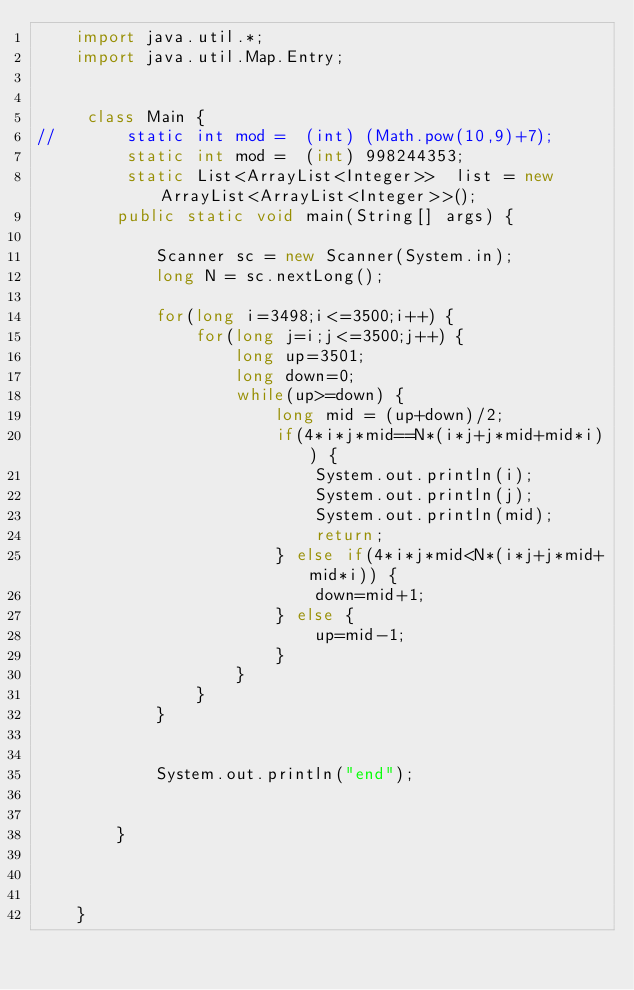<code> <loc_0><loc_0><loc_500><loc_500><_Java_>	import java.util.*;
	import java.util.Map.Entry;
	 
	 
	 class Main {
//		 static int mod =  (int) (Math.pow(10,9)+7);
		 static int mod =  (int) 998244353;
		 static List<ArrayList<Integer>>  list = new ArrayList<ArrayList<Integer>>();
	    public static void main(String[] args) {
	    	
	        Scanner sc = new Scanner(System.in);
	        long N = sc.nextLong();	

	        for(long i=3498;i<=3500;i++) {
	        	for(long j=i;j<=3500;j++) {
	        		long up=3501;
	        		long down=0;
	        		while(up>=down) {
	        			long mid = (up+down)/2;
		        		if(4*i*j*mid==N*(i*j+j*mid+mid*i)) {
	        				System.out.println(i);
	        				System.out.println(j);
	        				System.out.println(mid);
	        				return;
	        			} else if(4*i*j*mid<N*(i*j+j*mid+mid*i)) {
	        				down=mid+1;
	        			} else {
	        				up=mid-1;
	        			}
	        		}
	        	}
	        }
	        
	        
	        System.out.println("end");
	        

	    }
	    
	    

	}</code> 